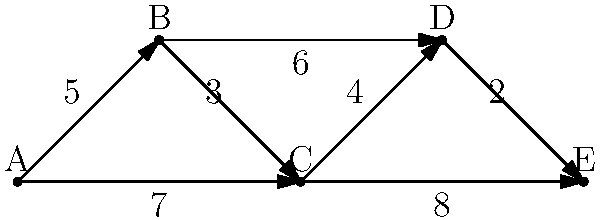In the military logistics network diagram above, nodes represent supply depots, and edges represent supply routes with their respective transportation times in hours. Identify the critical supply route that, if disrupted, would most significantly impact the overall efficiency of the network in terms of time delay from depot A to depot E. To identify the critical supply route, we need to analyze the network and find the path that offers the shortest total time from depot A to depot E. Then, we'll determine which edge in this path, if removed, would cause the greatest increase in travel time.

Step 1: Identify all possible paths from A to E and their total times:
1. A → B → C → D → E: 5 + 3 + 4 + 2 = 14 hours
2. A → B → D → E: 5 + 6 + 2 = 13 hours
3. A → C → D → E: 7 + 4 + 2 = 13 hours
4. A → C → E: 7 + 8 = 15 hours

Step 2: The shortest paths are A → B → D → E and A → C → D → E, both taking 13 hours.

Step 3: Analyze the impact of removing each edge in these paths:
- Removing A → B: Forces path through A → C, increasing time to 13 hours (no change)
- Removing B → D: Forces path through B → C → D, increasing time to 14 hours (+1 hour)
- Removing D → E: Forces path through C → E, increasing time to 17 hours (+4 hours)
- Removing A → C: Forces path through A → B, increasing time to 13 hours (no change)
- Removing C → D: Forces path through C → E, increasing time to 15 hours (+2 hours)

Step 4: The edge that causes the greatest time increase when removed is D → E, increasing the total time by 4 hours.

Therefore, the critical supply route is the edge connecting depot D to depot E.
Answer: D → E 